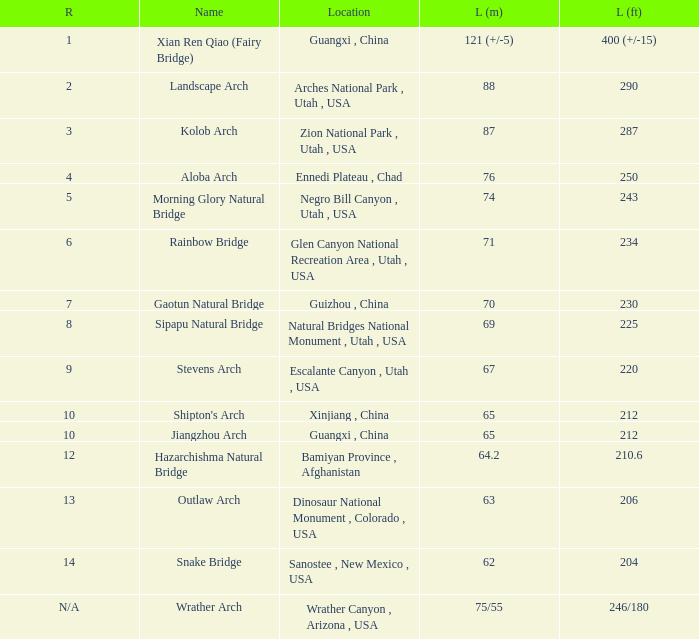Where is the longest arch with a length in meters of 64.2? Bamiyan Province , Afghanistan. 